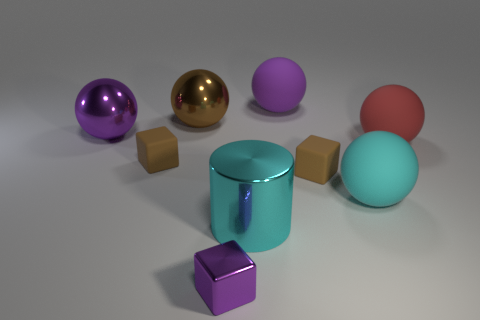Subtract 1 spheres. How many spheres are left? 4 Subtract all cyan balls. How many balls are left? 4 Subtract all brown spheres. How many spheres are left? 4 Subtract all green spheres. Subtract all red cubes. How many spheres are left? 5 Subtract all cylinders. How many objects are left? 8 Add 1 large yellow rubber cubes. How many large yellow rubber cubes exist? 1 Subtract 0 yellow balls. How many objects are left? 9 Subtract all brown things. Subtract all large cylinders. How many objects are left? 5 Add 8 brown metal things. How many brown metal things are left? 9 